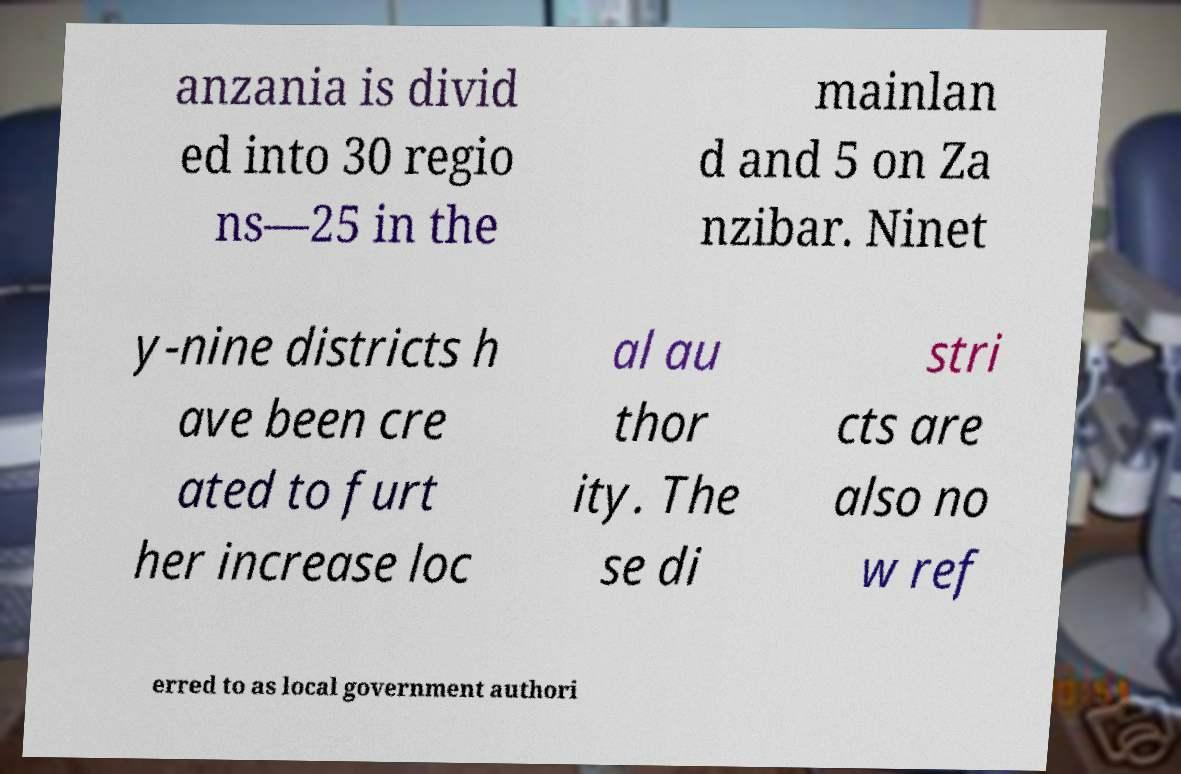Please identify and transcribe the text found in this image. anzania is divid ed into 30 regio ns—25 in the mainlan d and 5 on Za nzibar. Ninet y-nine districts h ave been cre ated to furt her increase loc al au thor ity. The se di stri cts are also no w ref erred to as local government authori 